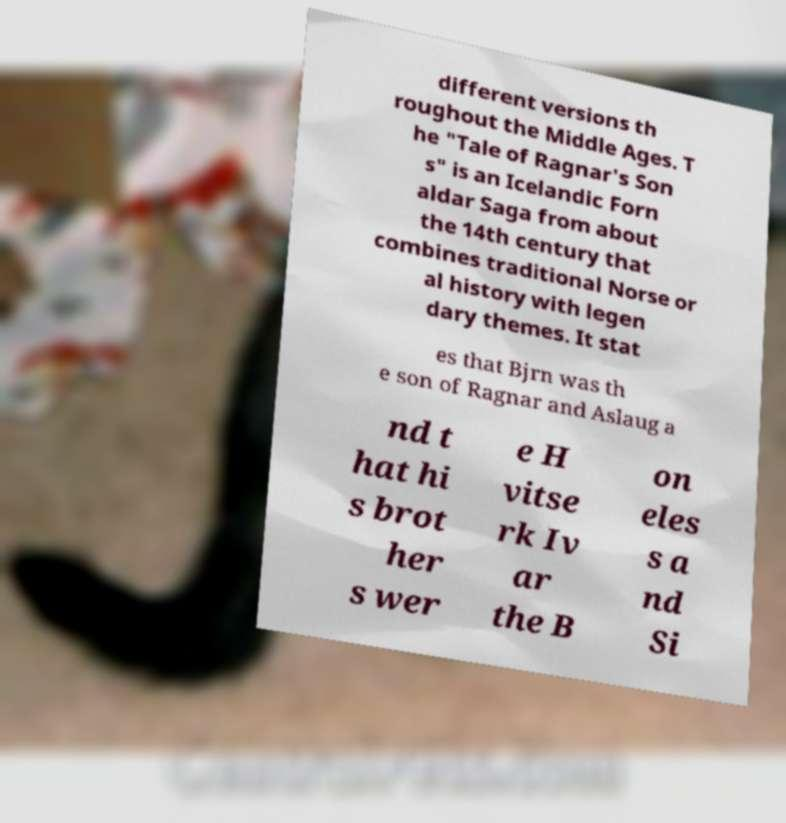Could you extract and type out the text from this image? different versions th roughout the Middle Ages. T he "Tale of Ragnar's Son s" is an Icelandic Forn aldar Saga from about the 14th century that combines traditional Norse or al history with legen dary themes. It stat es that Bjrn was th e son of Ragnar and Aslaug a nd t hat hi s brot her s wer e H vitse rk Iv ar the B on eles s a nd Si 